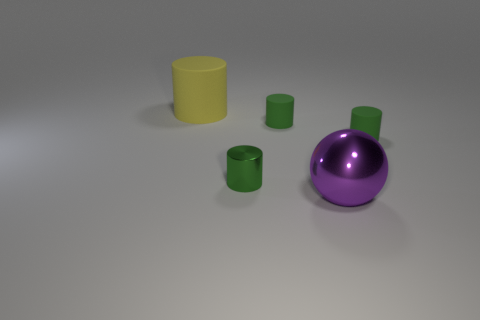Subtract all large cylinders. How many cylinders are left? 3 Subtract all brown blocks. How many green cylinders are left? 3 Add 2 tiny brown matte things. How many objects exist? 7 Subtract 1 cylinders. How many cylinders are left? 3 Subtract all yellow cylinders. How many cylinders are left? 3 Subtract all purple cylinders. Subtract all brown spheres. How many cylinders are left? 4 Add 3 tiny metal cylinders. How many tiny metal cylinders are left? 4 Add 2 small green objects. How many small green objects exist? 5 Subtract 0 green cubes. How many objects are left? 5 Subtract all cylinders. How many objects are left? 1 